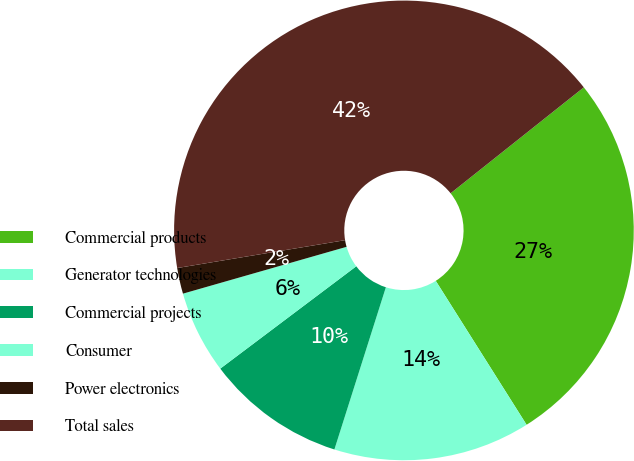<chart> <loc_0><loc_0><loc_500><loc_500><pie_chart><fcel>Commercial products<fcel>Generator technologies<fcel>Commercial projects<fcel>Consumer<fcel>Power electronics<fcel>Total sales<nl><fcel>26.73%<fcel>13.85%<fcel>9.84%<fcel>5.83%<fcel>1.82%<fcel>41.92%<nl></chart> 